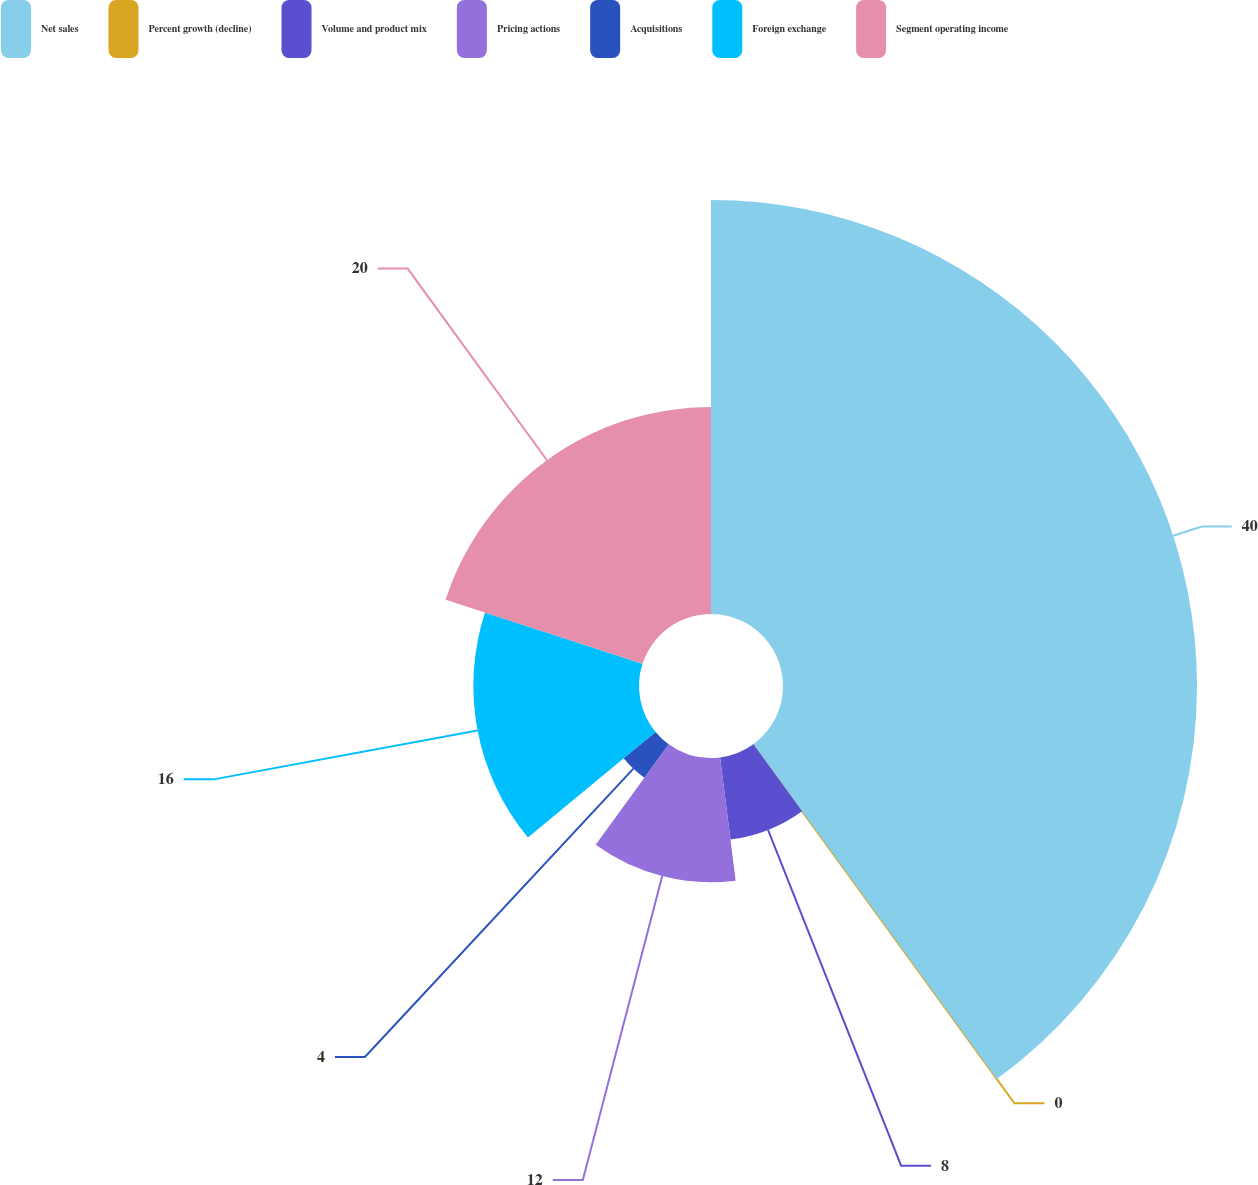<chart> <loc_0><loc_0><loc_500><loc_500><pie_chart><fcel>Net sales<fcel>Percent growth (decline)<fcel>Volume and product mix<fcel>Pricing actions<fcel>Acquisitions<fcel>Foreign exchange<fcel>Segment operating income<nl><fcel>39.99%<fcel>0.0%<fcel>8.0%<fcel>12.0%<fcel>4.0%<fcel>16.0%<fcel>20.0%<nl></chart> 